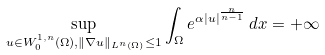<formula> <loc_0><loc_0><loc_500><loc_500>\sup _ { u \in W ^ { 1 , n } _ { 0 } ( \Omega ) , \| \nabla u \| _ { L ^ { n } ( \Omega ) } \leq 1 } \int _ { \Omega } e ^ { \alpha | u | ^ { \frac { n } { n - 1 } } } \, d x = + \infty</formula> 